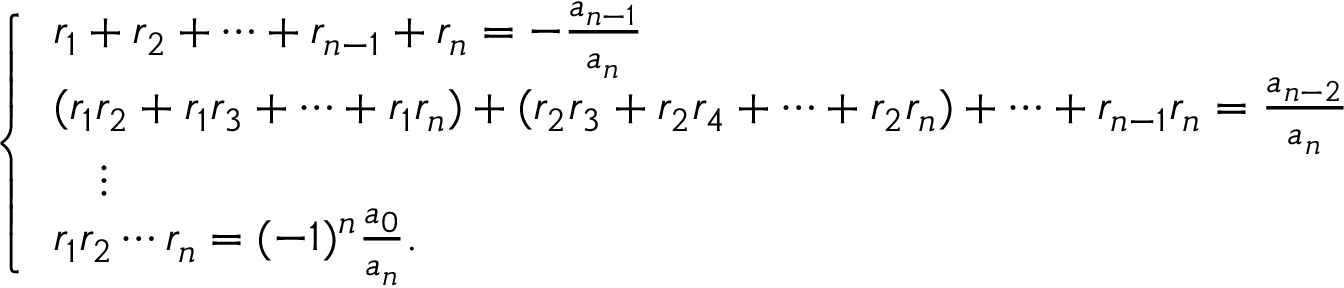<formula> <loc_0><loc_0><loc_500><loc_500>{ \left \{ \begin{array} { l l } { r _ { 1 } + r _ { 2 } + \dots + r _ { n - 1 } + r _ { n } = - { \frac { a _ { n - 1 } } { a _ { n } } } } \\ { ( r _ { 1 } r _ { 2 } + r _ { 1 } r _ { 3 } + \cdots + r _ { 1 } r _ { n } ) + ( r _ { 2 } r _ { 3 } + r _ { 2 } r _ { 4 } + \cdots + r _ { 2 } r _ { n } ) + \cdots + r _ { n - 1 } r _ { n } = { \frac { a _ { n - 2 } } { a _ { n } } } } \\ { \quad \vdots } \\ { r _ { 1 } r _ { 2 } \cdots r _ { n } = ( - 1 ) ^ { n } { \frac { a _ { 0 } } { a _ { n } } } . } \end{array} }</formula> 